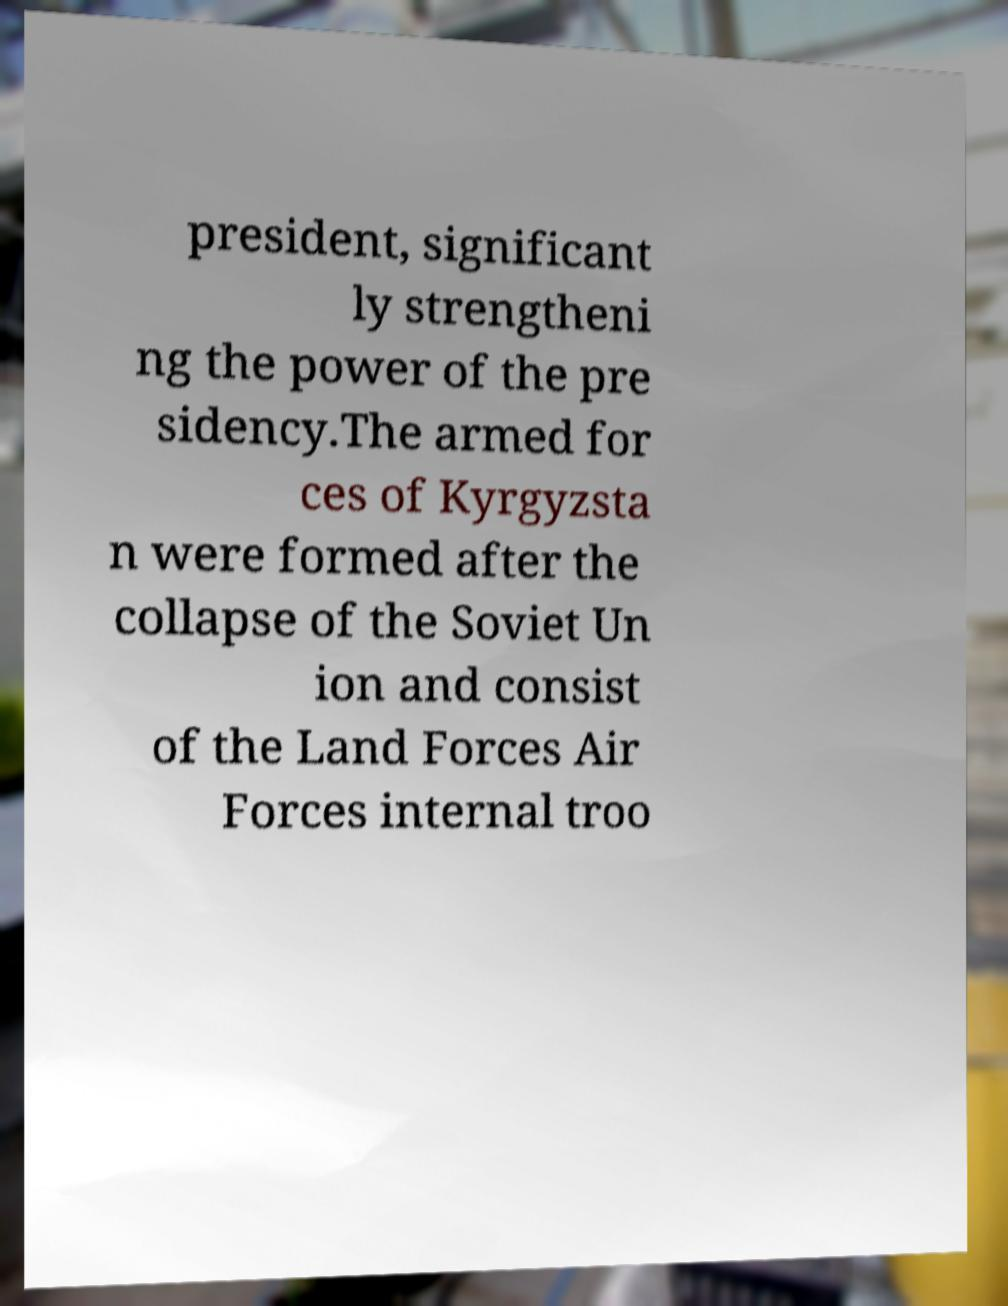Can you accurately transcribe the text from the provided image for me? president, significant ly strengtheni ng the power of the pre sidency.The armed for ces of Kyrgyzsta n were formed after the collapse of the Soviet Un ion and consist of the Land Forces Air Forces internal troo 